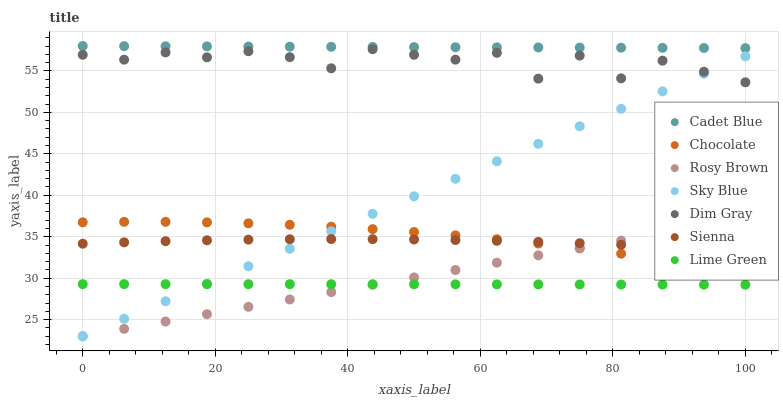Does Lime Green have the minimum area under the curve?
Answer yes or no. Yes. Does Cadet Blue have the maximum area under the curve?
Answer yes or no. Yes. Does Rosy Brown have the minimum area under the curve?
Answer yes or no. No. Does Rosy Brown have the maximum area under the curve?
Answer yes or no. No. Is Rosy Brown the smoothest?
Answer yes or no. Yes. Is Dim Gray the roughest?
Answer yes or no. Yes. Is Chocolate the smoothest?
Answer yes or no. No. Is Chocolate the roughest?
Answer yes or no. No. Does Rosy Brown have the lowest value?
Answer yes or no. Yes. Does Chocolate have the lowest value?
Answer yes or no. No. Does Cadet Blue have the highest value?
Answer yes or no. Yes. Does Rosy Brown have the highest value?
Answer yes or no. No. Is Dim Gray less than Cadet Blue?
Answer yes or no. Yes. Is Dim Gray greater than Sienna?
Answer yes or no. Yes. Does Rosy Brown intersect Lime Green?
Answer yes or no. Yes. Is Rosy Brown less than Lime Green?
Answer yes or no. No. Is Rosy Brown greater than Lime Green?
Answer yes or no. No. Does Dim Gray intersect Cadet Blue?
Answer yes or no. No. 